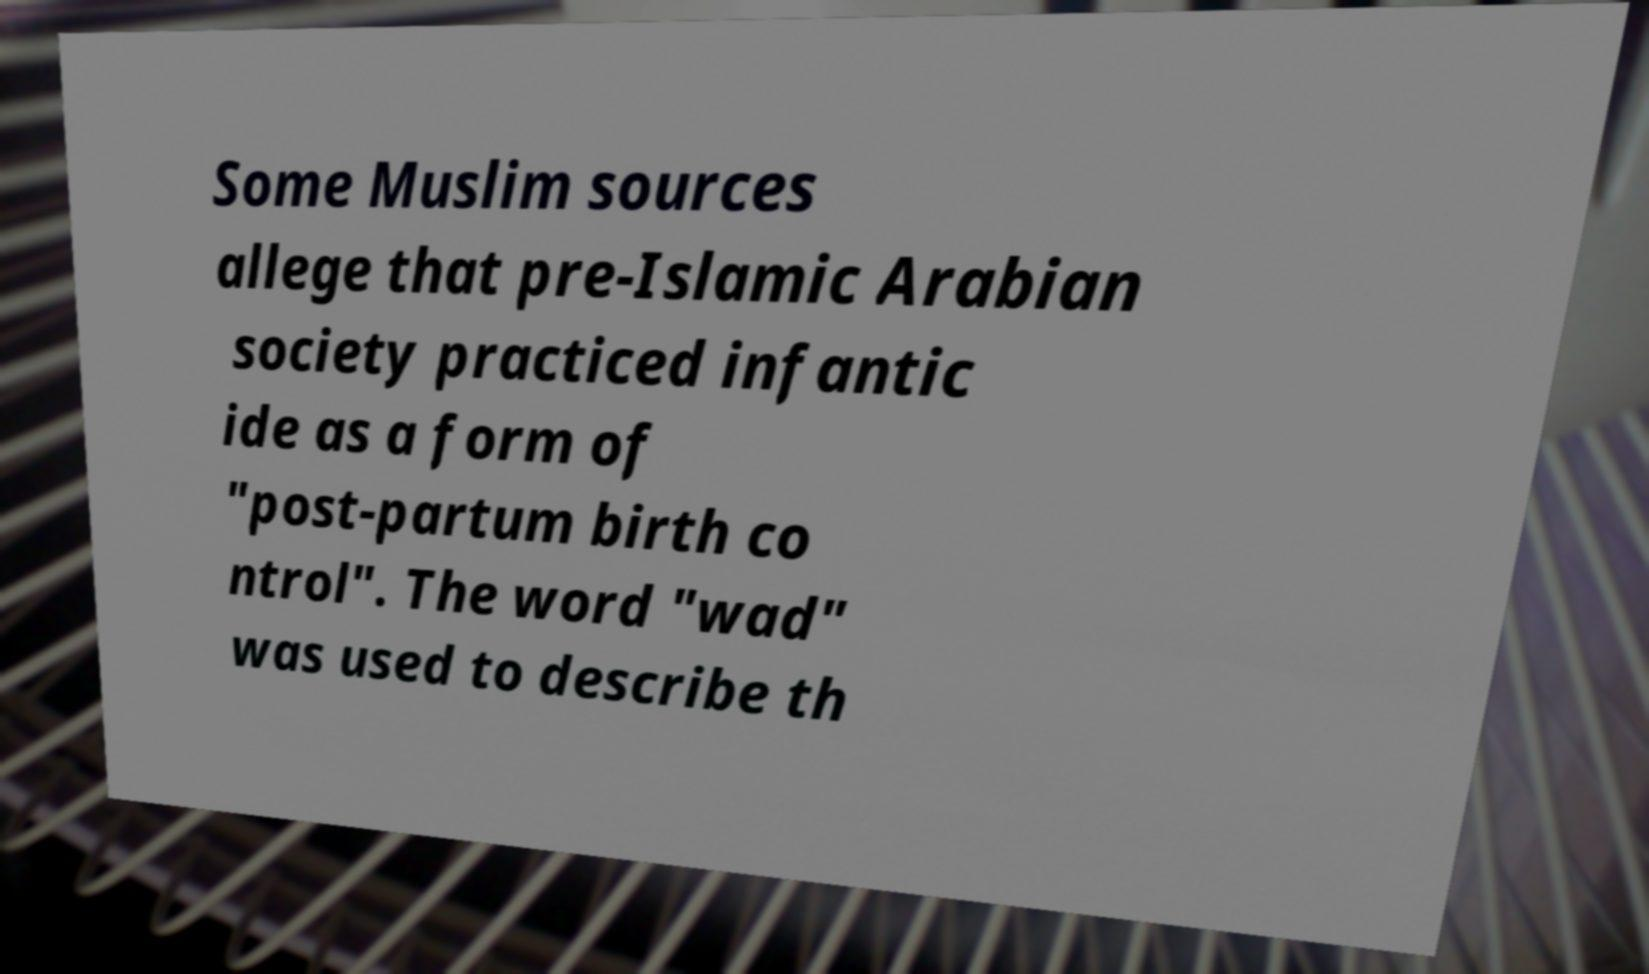Could you assist in decoding the text presented in this image and type it out clearly? Some Muslim sources allege that pre-Islamic Arabian society practiced infantic ide as a form of "post-partum birth co ntrol". The word "wad" was used to describe th 